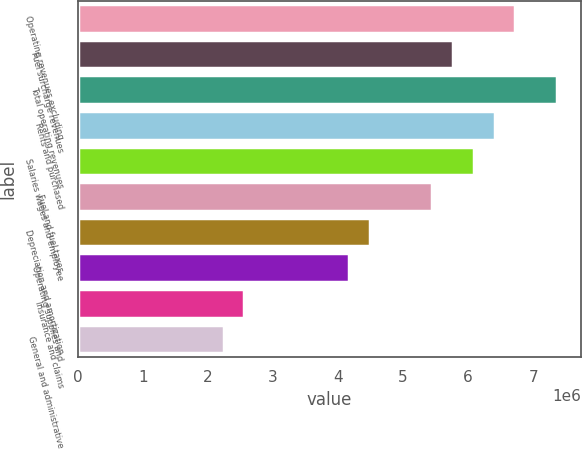Convert chart to OTSL. <chart><loc_0><loc_0><loc_500><loc_500><bar_chart><fcel>Operating revenues excluding<fcel>Fuel surcharge revenues<fcel>Total operating revenues<fcel>Rents and purchased<fcel>Salaries wages and employee<fcel>Fuel and fuel taxes<fcel>Depreciation and amortization<fcel>Operating supplies and<fcel>Insurance and claims<fcel>General and administrative<nl><fcel>6.72697e+06<fcel>5.76598e+06<fcel>7.36764e+06<fcel>6.40664e+06<fcel>6.08631e+06<fcel>5.44565e+06<fcel>4.48465e+06<fcel>4.16432e+06<fcel>2.56266e+06<fcel>2.24232e+06<nl></chart> 